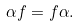<formula> <loc_0><loc_0><loc_500><loc_500>\alpha f = f \alpha .</formula> 